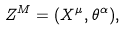<formula> <loc_0><loc_0><loc_500><loc_500>Z ^ { M } = ( X ^ { \mu } , \theta ^ { \alpha } ) ,</formula> 